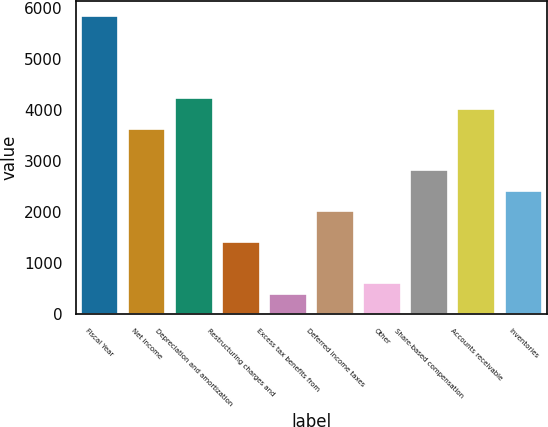<chart> <loc_0><loc_0><loc_500><loc_500><bar_chart><fcel>Fiscal Year<fcel>Net income<fcel>Depreciation and amortization<fcel>Restructuring charges and<fcel>Excess tax benefits from<fcel>Deferred income taxes<fcel>Other<fcel>Share-based compensation<fcel>Accounts receivable<fcel>Inventories<nl><fcel>5835.8<fcel>3622.6<fcel>4226.2<fcel>1409.4<fcel>403.4<fcel>2013<fcel>604.6<fcel>2817.8<fcel>4025<fcel>2415.4<nl></chart> 